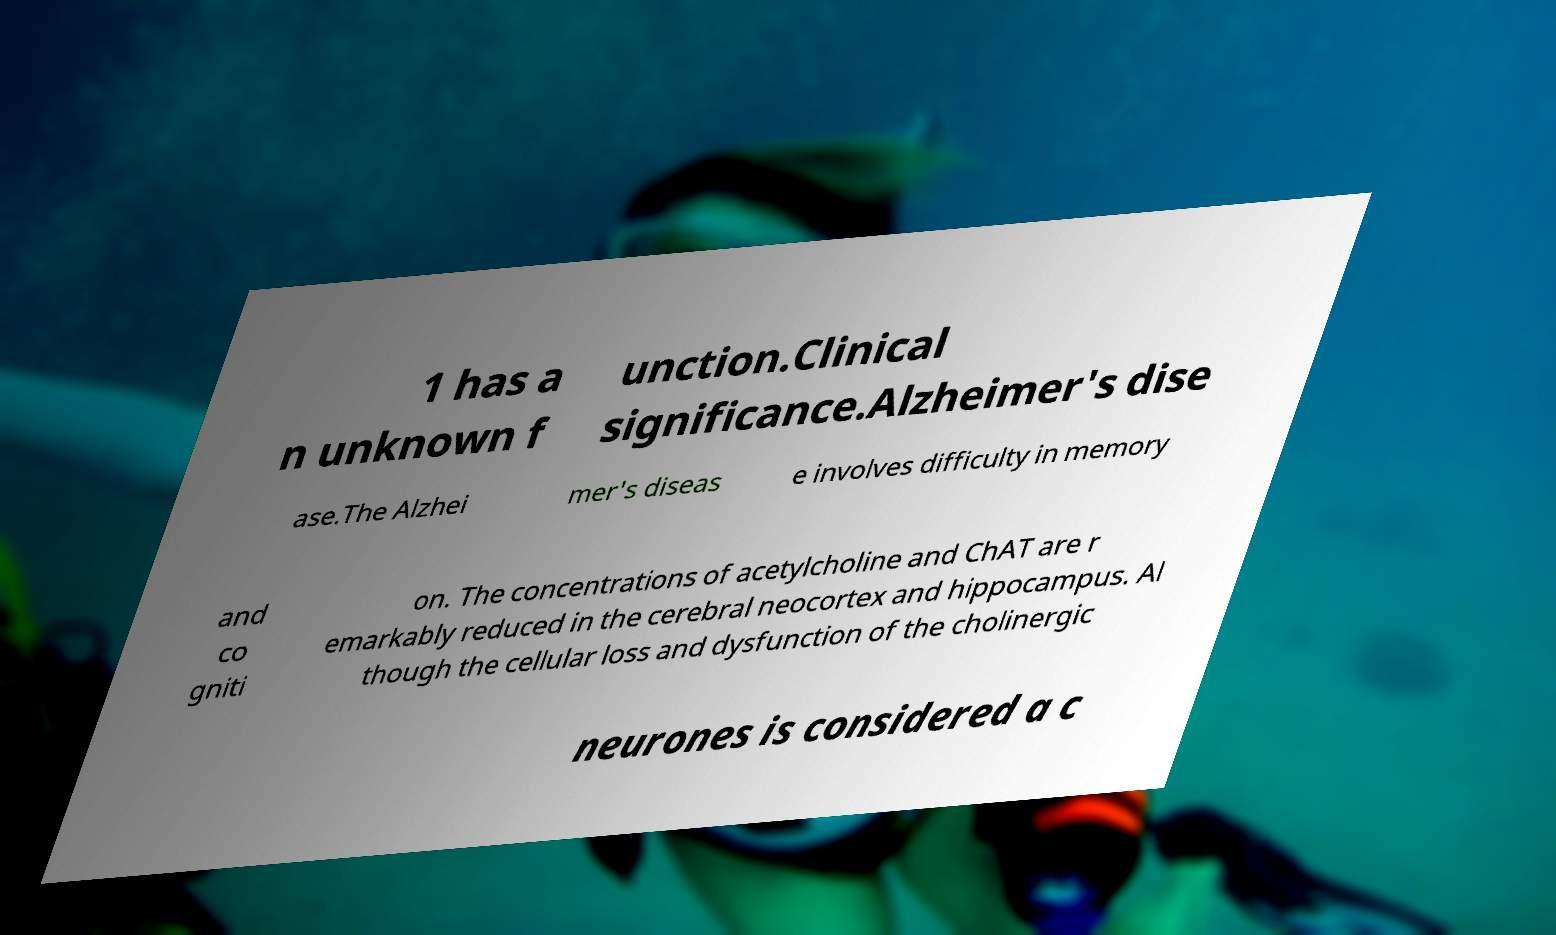Please read and relay the text visible in this image. What does it say? 1 has a n unknown f unction.Clinical significance.Alzheimer's dise ase.The Alzhei mer's diseas e involves difficulty in memory and co gniti on. The concentrations of acetylcholine and ChAT are r emarkably reduced in the cerebral neocortex and hippocampus. Al though the cellular loss and dysfunction of the cholinergic neurones is considered a c 